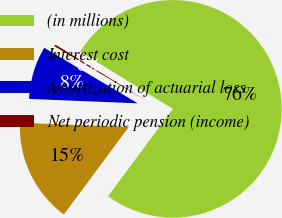Convert chart. <chart><loc_0><loc_0><loc_500><loc_500><pie_chart><fcel>(in millions)<fcel>Interest cost<fcel>Amortization of actuarial loss<fcel>Net periodic pension (income)<nl><fcel>76.37%<fcel>15.49%<fcel>7.88%<fcel>0.27%<nl></chart> 